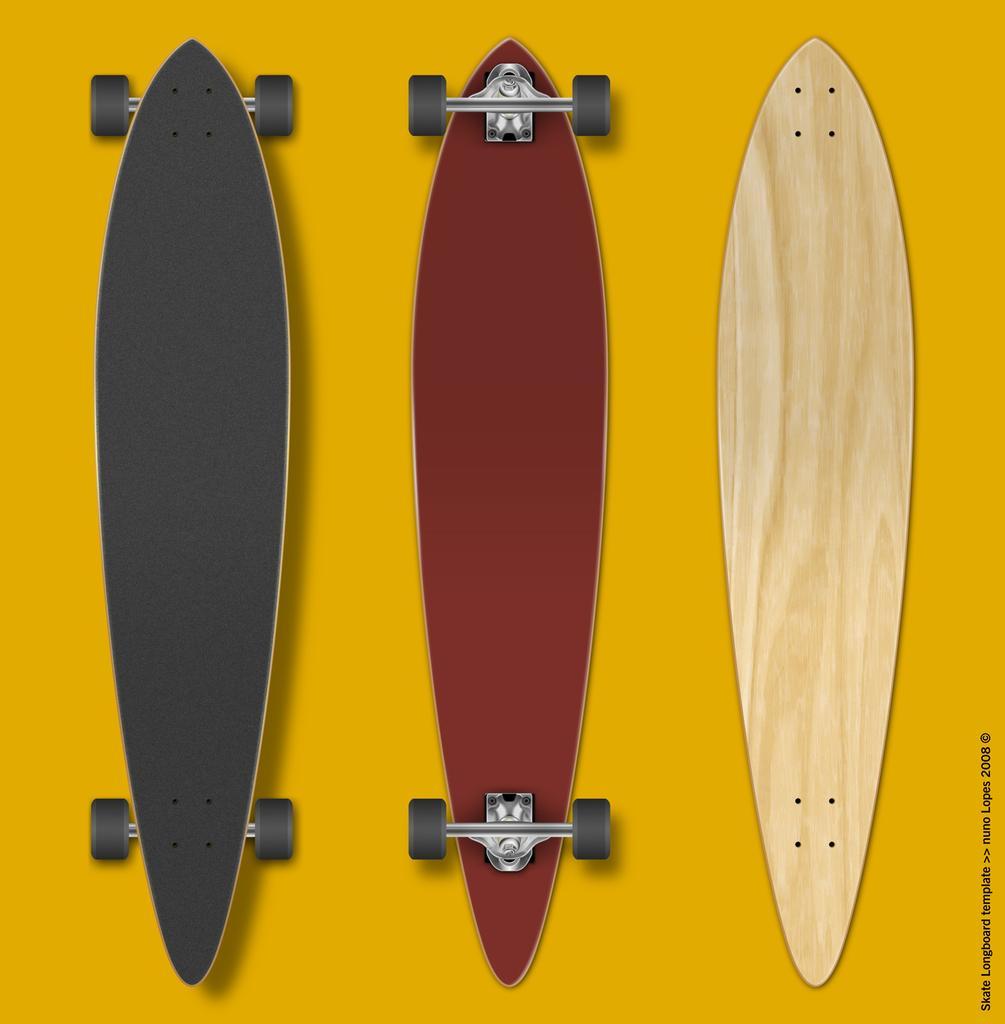Please provide a concise description of this image. In this image we can see two skateboards, and a wooden board on the yellow colored surface, also we can see the text on the image. 